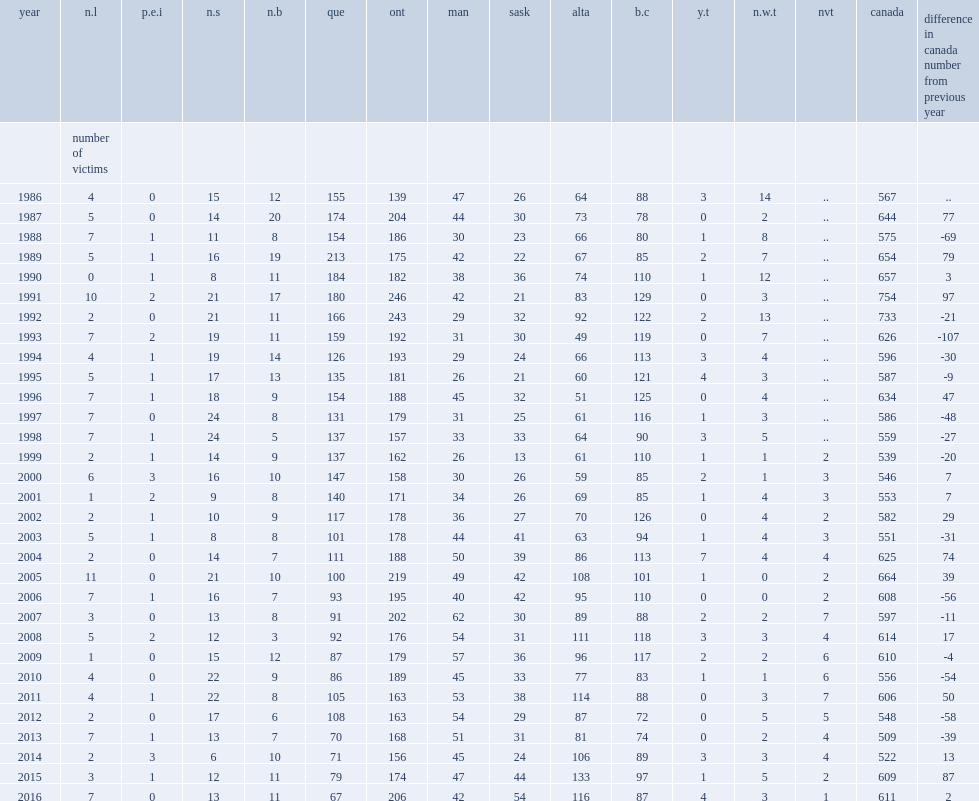What was the number of homicide victims reported in canada in 2016? 611.0. What were the changes in number of victims in alberta , quebec and british columbia from 2015 to 2016 respectively? -17 -12 -10. 